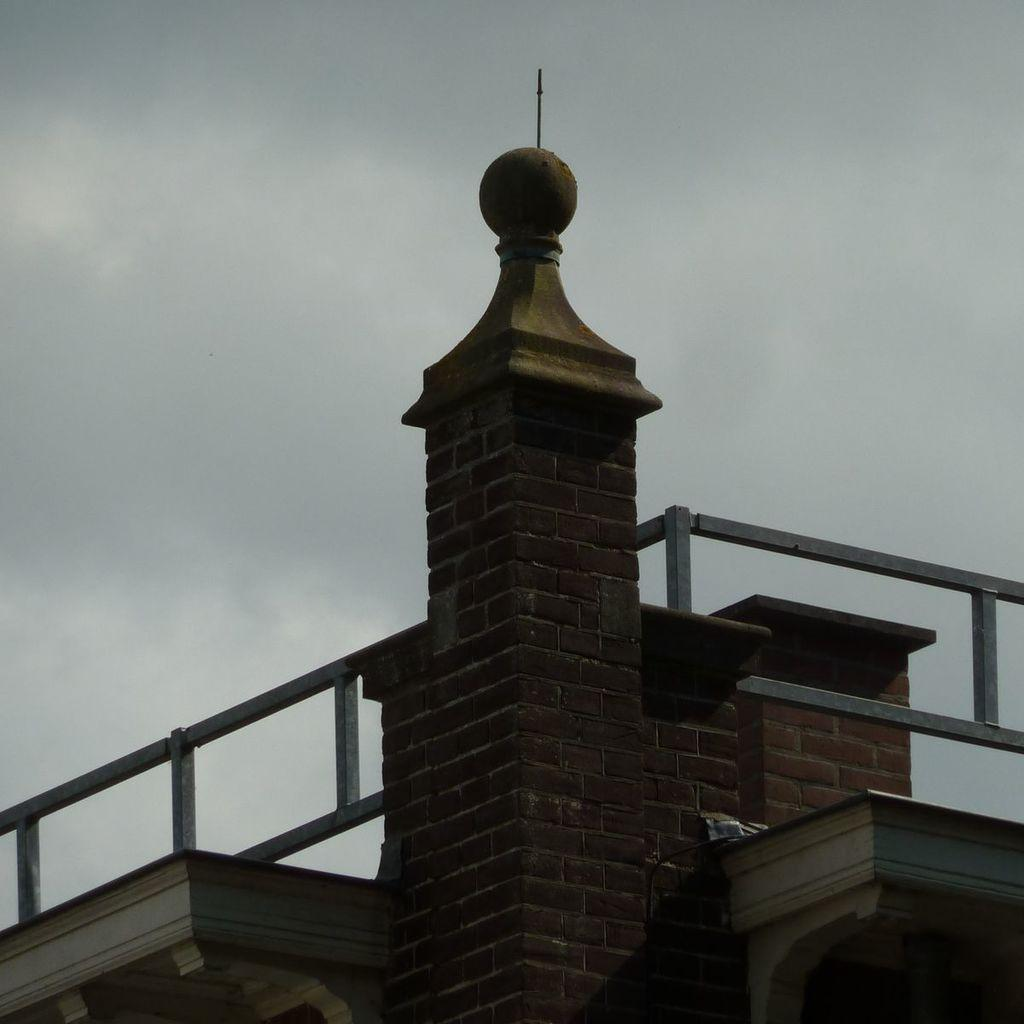What type of structure is present in the image? There is a building in the image. What feature can be seen on the building or surrounding it? There are railings in the image. What can be seen in the sky in the image? Clouds are visible in the image. What else is visible in the sky in the image? The sky is visible in the image. How many pieces of lumber are stacked against the building in the image? There is no lumber present in the image. What type of line can be seen connecting the clouds in the image? There are no lines connecting the clouds in the image; the clouds are simply visible in the sky. 